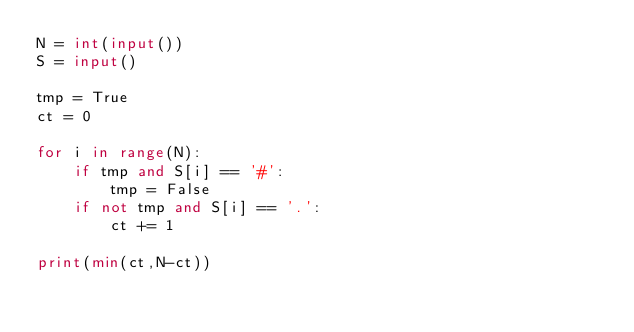Convert code to text. <code><loc_0><loc_0><loc_500><loc_500><_Python_>N = int(input())
S = input()

tmp = True
ct = 0

for i in range(N):
    if tmp and S[i] == '#':
        tmp = False
    if not tmp and S[i] == '.':
        ct += 1

print(min(ct,N-ct))</code> 